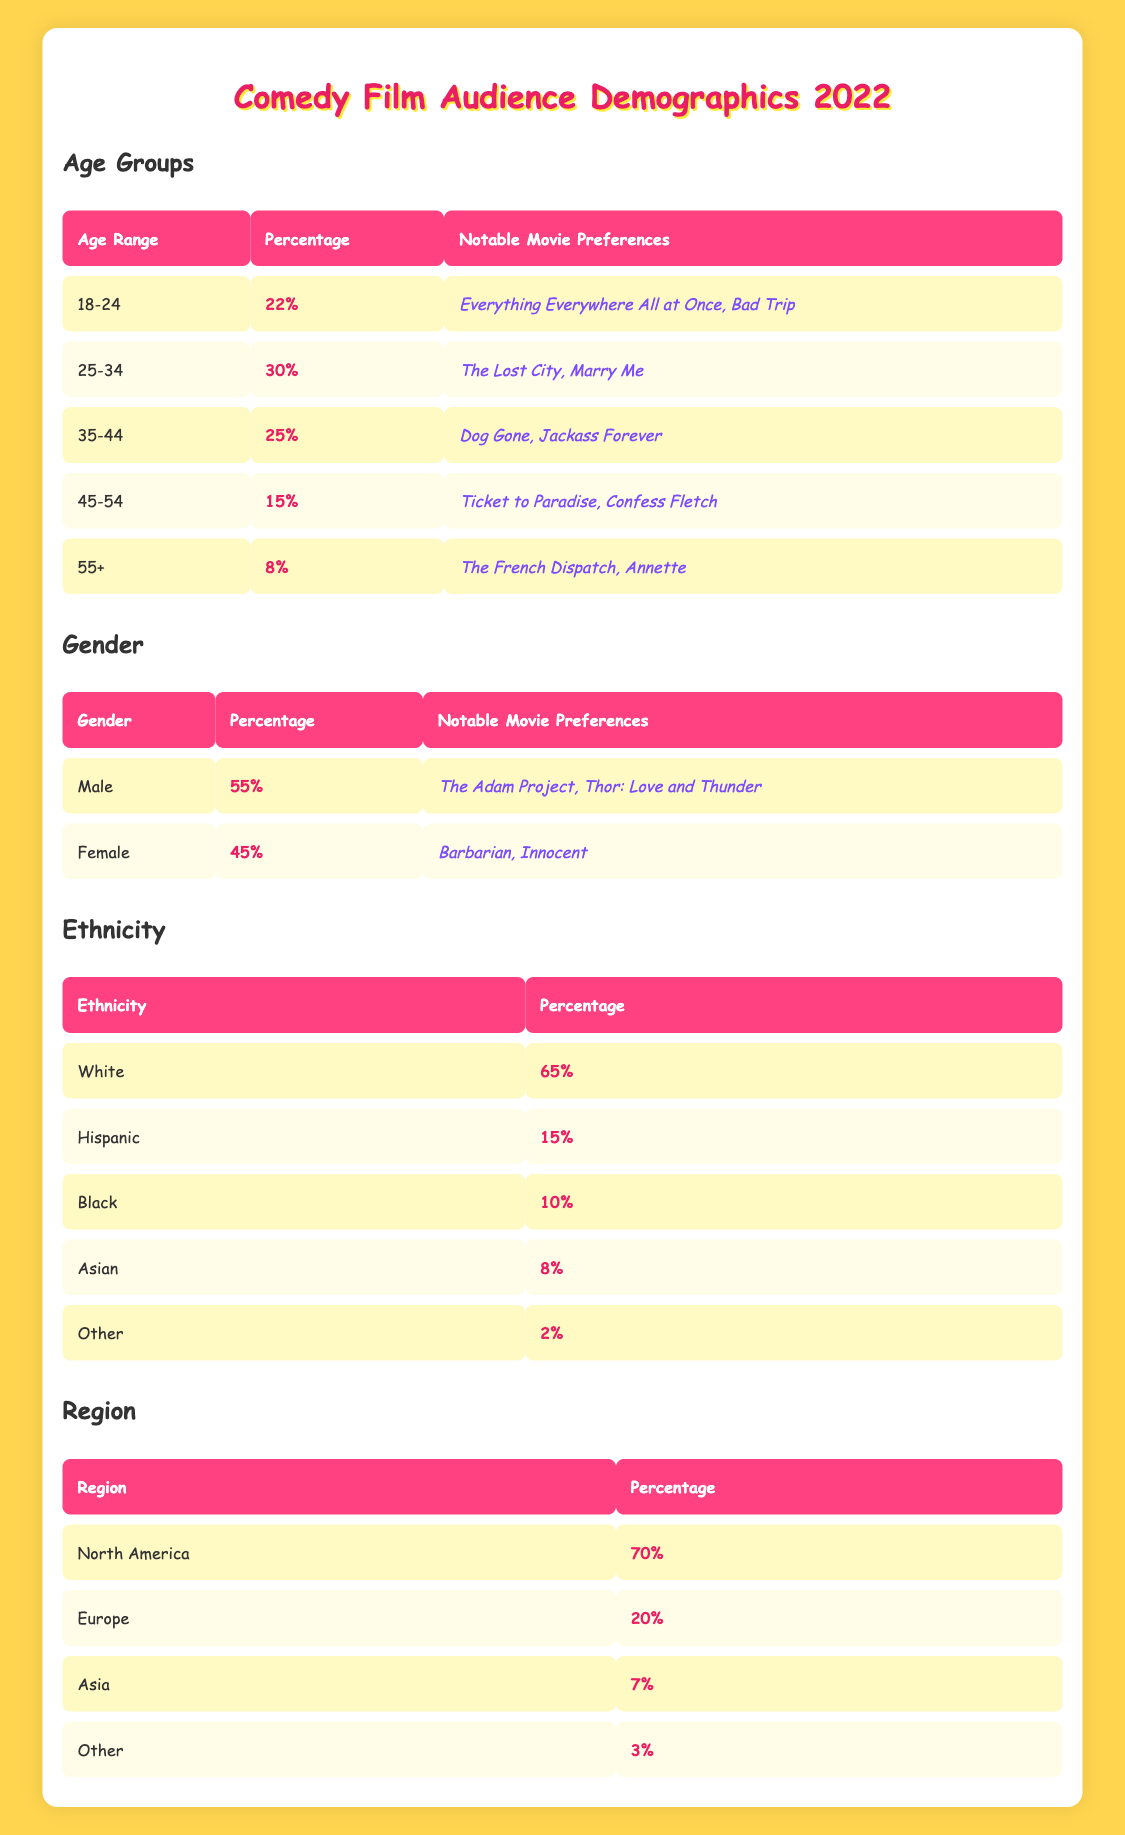What percentage of the comedy film audience in 2022 was aged 25-34? According to the table, the portion of the audience aged 25-34 is directly listed. The percentage for this age range is 30%.
Answer: 30% Which age group had the highest percentage of comedy film viewers in 2022? By examining the age groups, 25-34 clearly shows the highest percentage at 30%.
Answer: 25-34 Is the percentage of female comedy film viewers in 2022 greater than that of male viewers? The table shows male viewers at 55% and female viewers at 45%. Since 55% is greater than 45%, the statement is false.
Answer: No What is the combined percentage of the audience aged 45-54 and 55+? To find the combined percentage, we add the two age group percentages: 15% (for 45-54) + 8% (for 55+) equals 23%.
Answer: 23% In which region does the majority of comedy film audiences in 2022 come from, and what is the percentage? Analyzing the regions, North America has the highest percentage at 70%, which is listed directly in the region table.
Answer: North America, 70% What is the difference in percentage between White and Black comedy film audiences? The percentage for White is 65% and for Black is 10%. To find the difference, subtract 10% from 65%, which gives 55%.
Answer: 55% If we calculate the average percentage of all the age groups listed, what do we get? The average is calculated by adding the percentage of all age groups (22% + 30% + 25% + 15% + 8% = 100%), then dividing by the number of groups (5), giving an average of 20%.
Answer: 20% Is the percentage of Hispanic audiences greater than that of Asian audiences in comedy films? The Hispanic audience percentage is 15%, while the Asian audience percentage is 8%. Since 15% is greater than 8%, the statement is true.
Answer: Yes What notable movies were preferred by the 35-44 age group? A quick look at the age group data shows that the notable movies for the 35-44 age group are "Dog Gone" and "Jackass Forever".
Answer: Dog Gone, Jackass Forever 